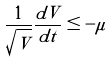<formula> <loc_0><loc_0><loc_500><loc_500>\frac { 1 } { \sqrt { V } } \frac { d V } { d t } \leq - \mu</formula> 